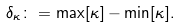<formula> <loc_0><loc_0><loc_500><loc_500>\delta _ { \kappa } \colon = \max [ \kappa ] - \min [ \kappa ] .</formula> 